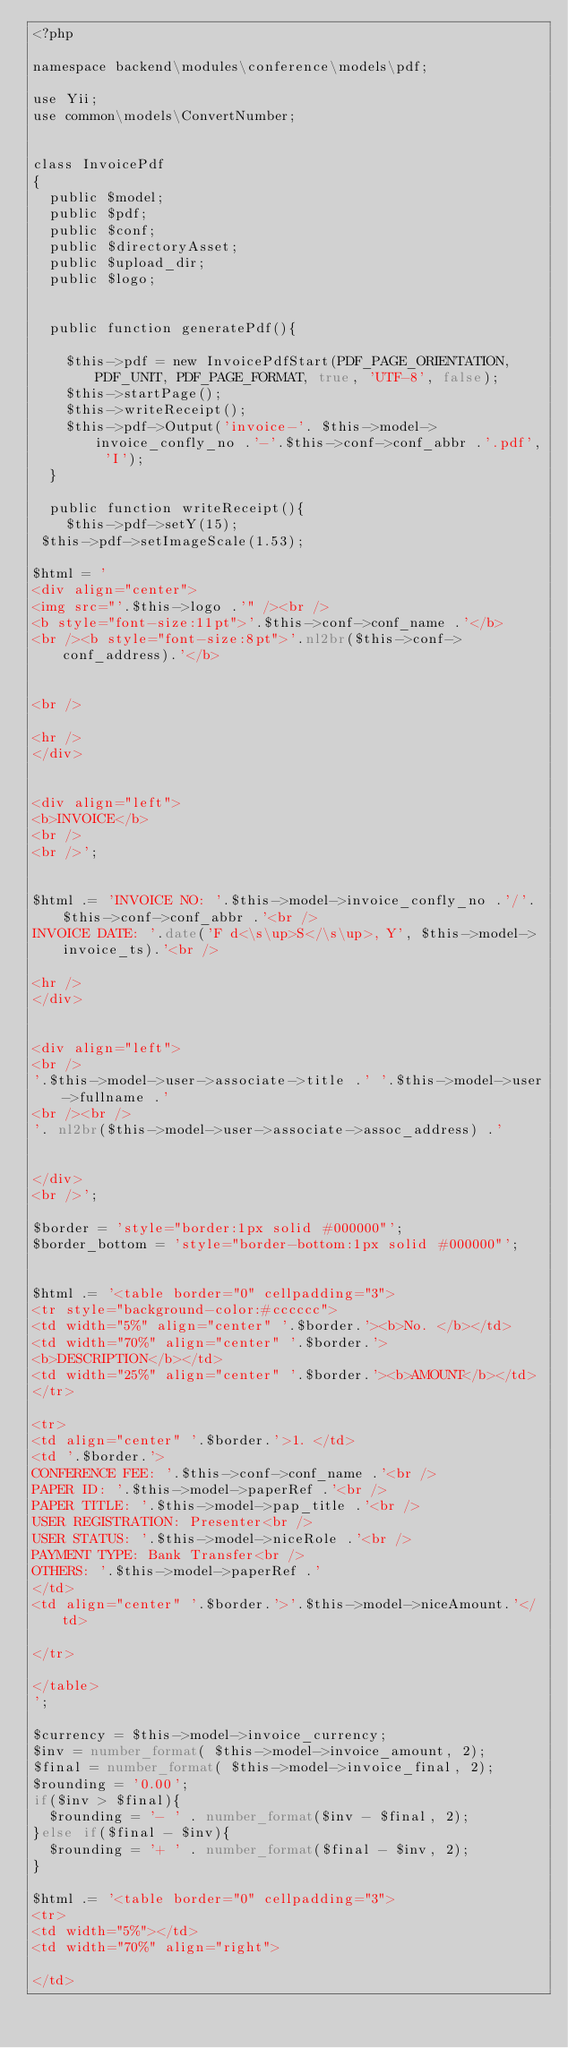<code> <loc_0><loc_0><loc_500><loc_500><_PHP_><?php

namespace backend\modules\conference\models\pdf;

use Yii;
use common\models\ConvertNumber;


class InvoicePdf
{
	public $model;
	public $pdf;
	public $conf;
	public $directoryAsset;
	public $upload_dir;
	public $logo;
	
	
	public function generatePdf(){

		$this->pdf = new InvoicePdfStart(PDF_PAGE_ORIENTATION, PDF_UNIT, PDF_PAGE_FORMAT, true, 'UTF-8', false);
		$this->startPage();
		$this->writeReceipt();
		$this->pdf->Output('invoice-'. $this->model->invoice_confly_no .'-'.$this->conf->conf_abbr .'.pdf', 'I');
	}
	
	public function writeReceipt(){
		$this->pdf->setY(15);
 $this->pdf->setImageScale(1.53);
 
$html = '
<div align="center">
<img src="'.$this->logo .'" /><br />
<b style="font-size:11pt">'.$this->conf->conf_name .'</b>
<br /><b style="font-size:8pt">'.nl2br($this->conf->conf_address).'</b>


<br />

<hr />
</div>


<div align="left">
<b>INVOICE</b>
<br />
<br />';


$html .= 'INVOICE NO: '.$this->model->invoice_confly_no .'/'.$this->conf->conf_abbr .'<br />
INVOICE DATE: '.date('F d<\s\up>S</\s\up>, Y', $this->model->invoice_ts).'<br />

<hr />
</div>


<div align="left">
<br />
'.$this->model->user->associate->title .' '.$this->model->user->fullname .'
<br /><br />
'. nl2br($this->model->user->associate->assoc_address) .'


</div>
<br />';

$border = 'style="border:1px solid #000000"';
$border_bottom = 'style="border-bottom:1px solid #000000"';


$html .= '<table border="0" cellpadding="3">
<tr style="background-color:#cccccc">
<td width="5%" align="center" '.$border.'><b>No. </b></td>
<td width="70%" align="center" '.$border.'>
<b>DESCRIPTION</b></td>
<td width="25%" align="center" '.$border.'><b>AMOUNT</b></td>
</tr>

<tr>
<td align="center" '.$border.'>1. </td>
<td '.$border.'>
CONFERENCE FEE: '.$this->conf->conf_name .'<br />
PAPER ID: '.$this->model->paperRef .'<br />
PAPER TITLE: '.$this->model->pap_title .'<br />
USER REGISTRATION: Presenter<br />
USER STATUS: '.$this->model->niceRole .'<br />
PAYMENT TYPE: Bank Transfer<br />
OTHERS: '.$this->model->paperRef .'
</td>
<td align="center" '.$border.'>'.$this->model->niceAmount.'</td>

</tr>

</table>
';

$currency = $this->model->invoice_currency;
$inv = number_format( $this->model->invoice_amount, 2);
$final = number_format( $this->model->invoice_final, 2);
$rounding = '0.00';
if($inv > $final){
	$rounding = '- ' . number_format($inv - $final, 2);
}else if($final - $inv){
	$rounding = '+ ' . number_format($final - $inv, 2);
}

$html .= '<table border="0" cellpadding="3">
<tr>
<td width="5%"></td>
<td width="70%" align="right">

</td></code> 